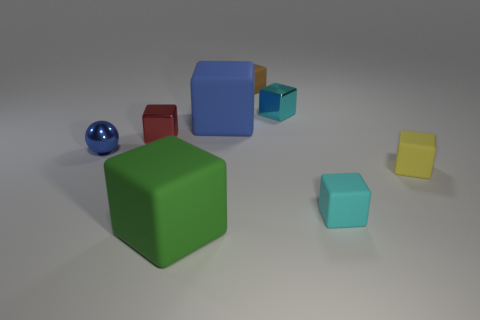How many objects are either cyan matte objects or small metallic blocks that are behind the blue matte cube?
Give a very brief answer. 2. What number of other things are there of the same shape as the cyan metallic object?
Your answer should be compact. 6. Are there fewer small cyan metallic things that are in front of the red object than small yellow matte objects that are in front of the green block?
Keep it short and to the point. No. The small cyan object that is the same material as the small blue object is what shape?
Offer a very short reply. Cube. Is there anything else that has the same color as the small metal ball?
Your answer should be very brief. Yes. What color is the shiny block right of the small cube that is to the left of the brown matte thing?
Offer a very short reply. Cyan. What is the material of the cyan cube in front of the metal cube that is right of the tiny rubber cube that is on the left side of the tiny cyan rubber object?
Provide a succinct answer. Rubber. What number of green things are the same size as the blue shiny sphere?
Your response must be concise. 0. What material is the cube that is to the left of the small yellow matte object and to the right of the cyan metal block?
Your answer should be compact. Rubber. There is a big green object; how many tiny cyan shiny objects are behind it?
Ensure brevity in your answer.  1. 